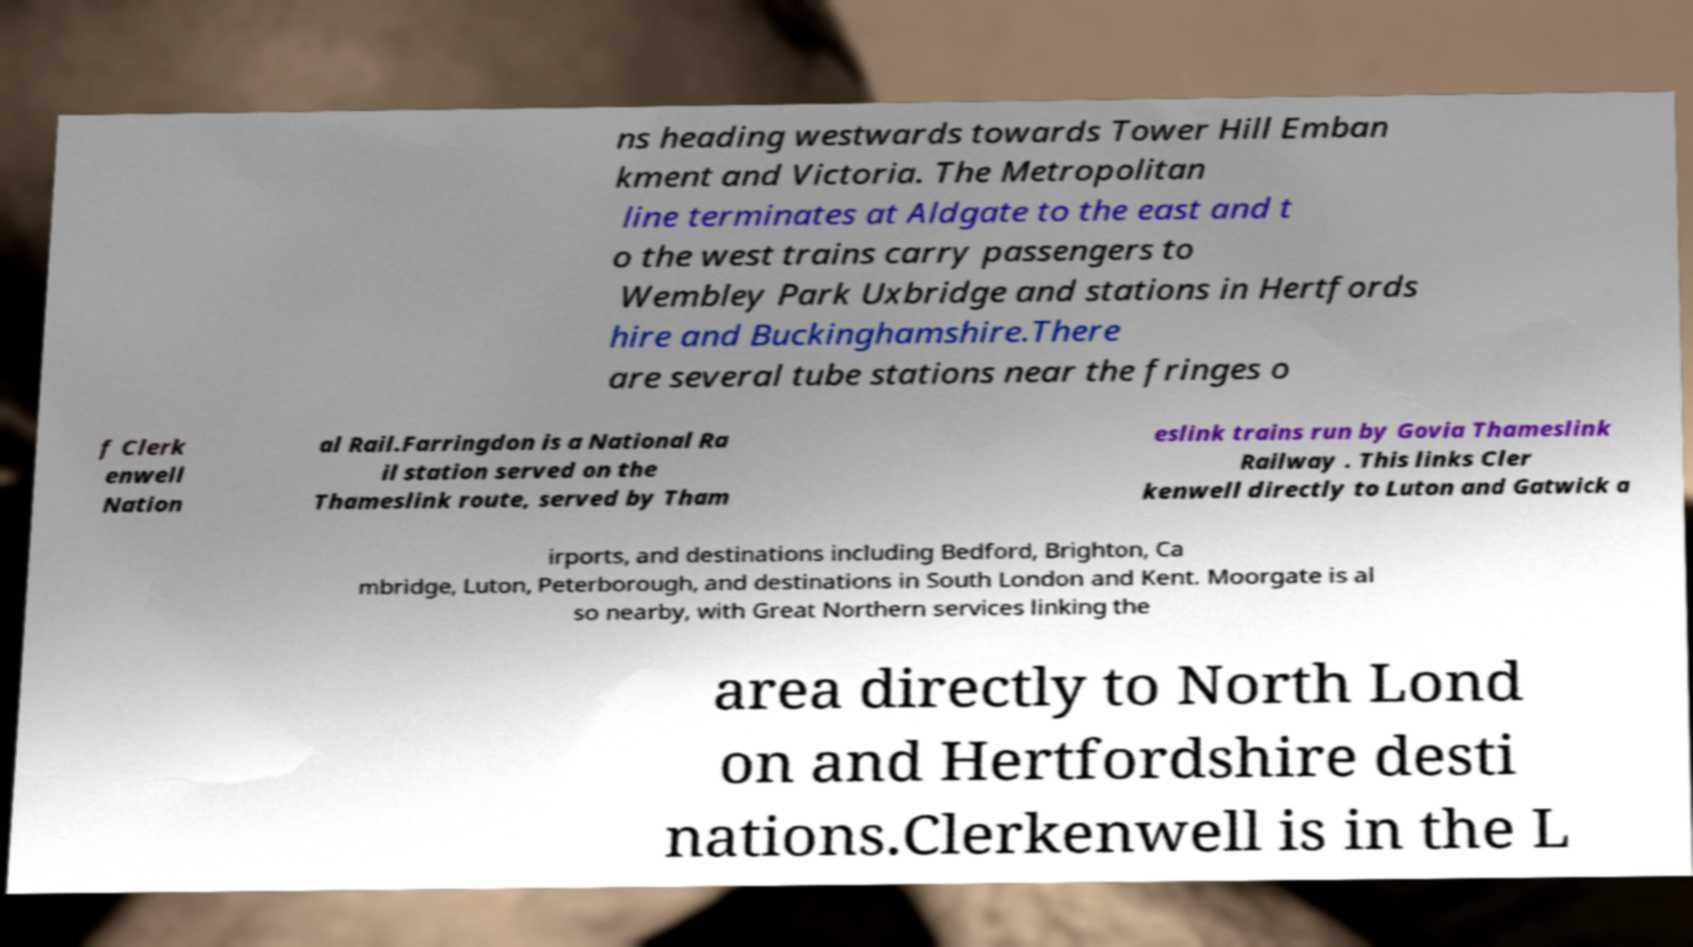What messages or text are displayed in this image? I need them in a readable, typed format. ns heading westwards towards Tower Hill Emban kment and Victoria. The Metropolitan line terminates at Aldgate to the east and t o the west trains carry passengers to Wembley Park Uxbridge and stations in Hertfords hire and Buckinghamshire.There are several tube stations near the fringes o f Clerk enwell Nation al Rail.Farringdon is a National Ra il station served on the Thameslink route, served by Tham eslink trains run by Govia Thameslink Railway . This links Cler kenwell directly to Luton and Gatwick a irports, and destinations including Bedford, Brighton, Ca mbridge, Luton, Peterborough, and destinations in South London and Kent. Moorgate is al so nearby, with Great Northern services linking the area directly to North Lond on and Hertfordshire desti nations.Clerkenwell is in the L 